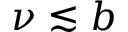<formula> <loc_0><loc_0><loc_500><loc_500>\nu \lesssim b</formula> 